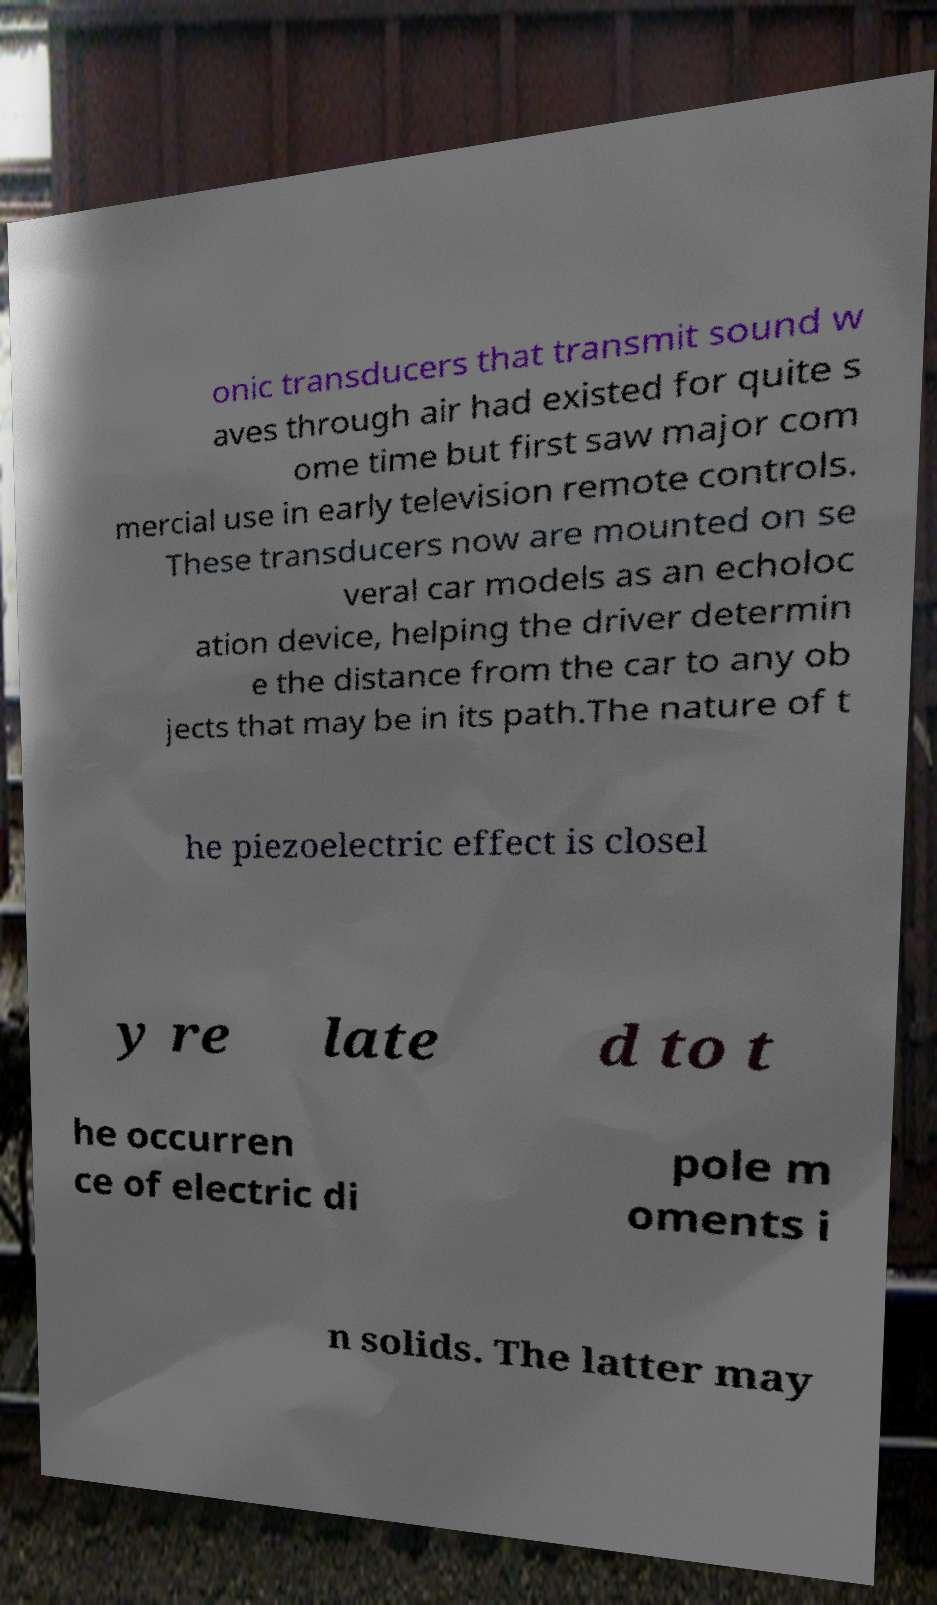Can you accurately transcribe the text from the provided image for me? onic transducers that transmit sound w aves through air had existed for quite s ome time but first saw major com mercial use in early television remote controls. These transducers now are mounted on se veral car models as an echoloc ation device, helping the driver determin e the distance from the car to any ob jects that may be in its path.The nature of t he piezoelectric effect is closel y re late d to t he occurren ce of electric di pole m oments i n solids. The latter may 